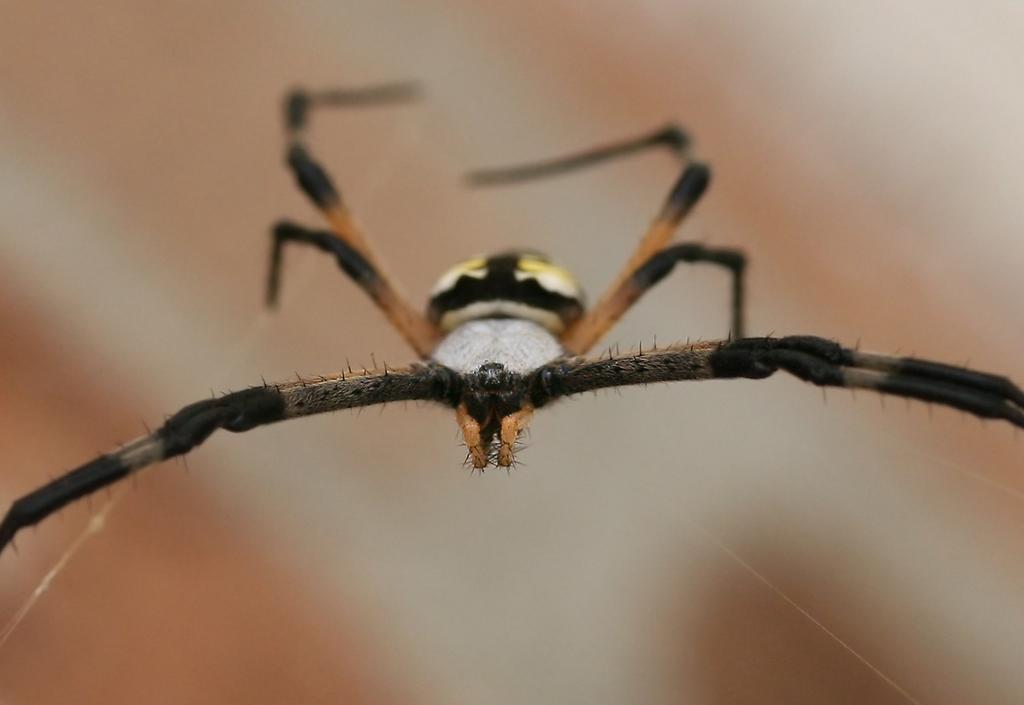Please provide a concise description of this image. In this image there is a spider and the background is blurred. 